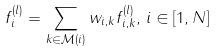Convert formula to latex. <formula><loc_0><loc_0><loc_500><loc_500>f _ { i } ^ { ( l ) } = \sum _ { k \in \mathcal { M } ( i ) } w _ { i , k } f _ { i , k } ^ { ( l ) } , \, i \in [ 1 , N ]</formula> 